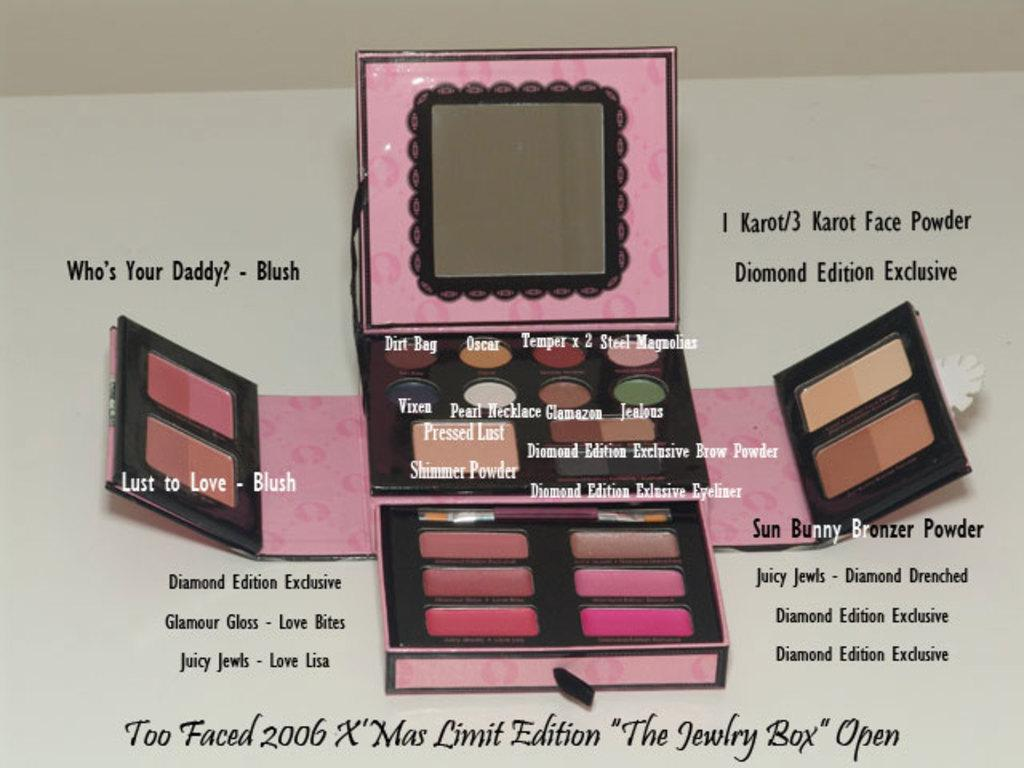<image>
Summarize the visual content of the image. Limited edition X mas makeup set with mirror 